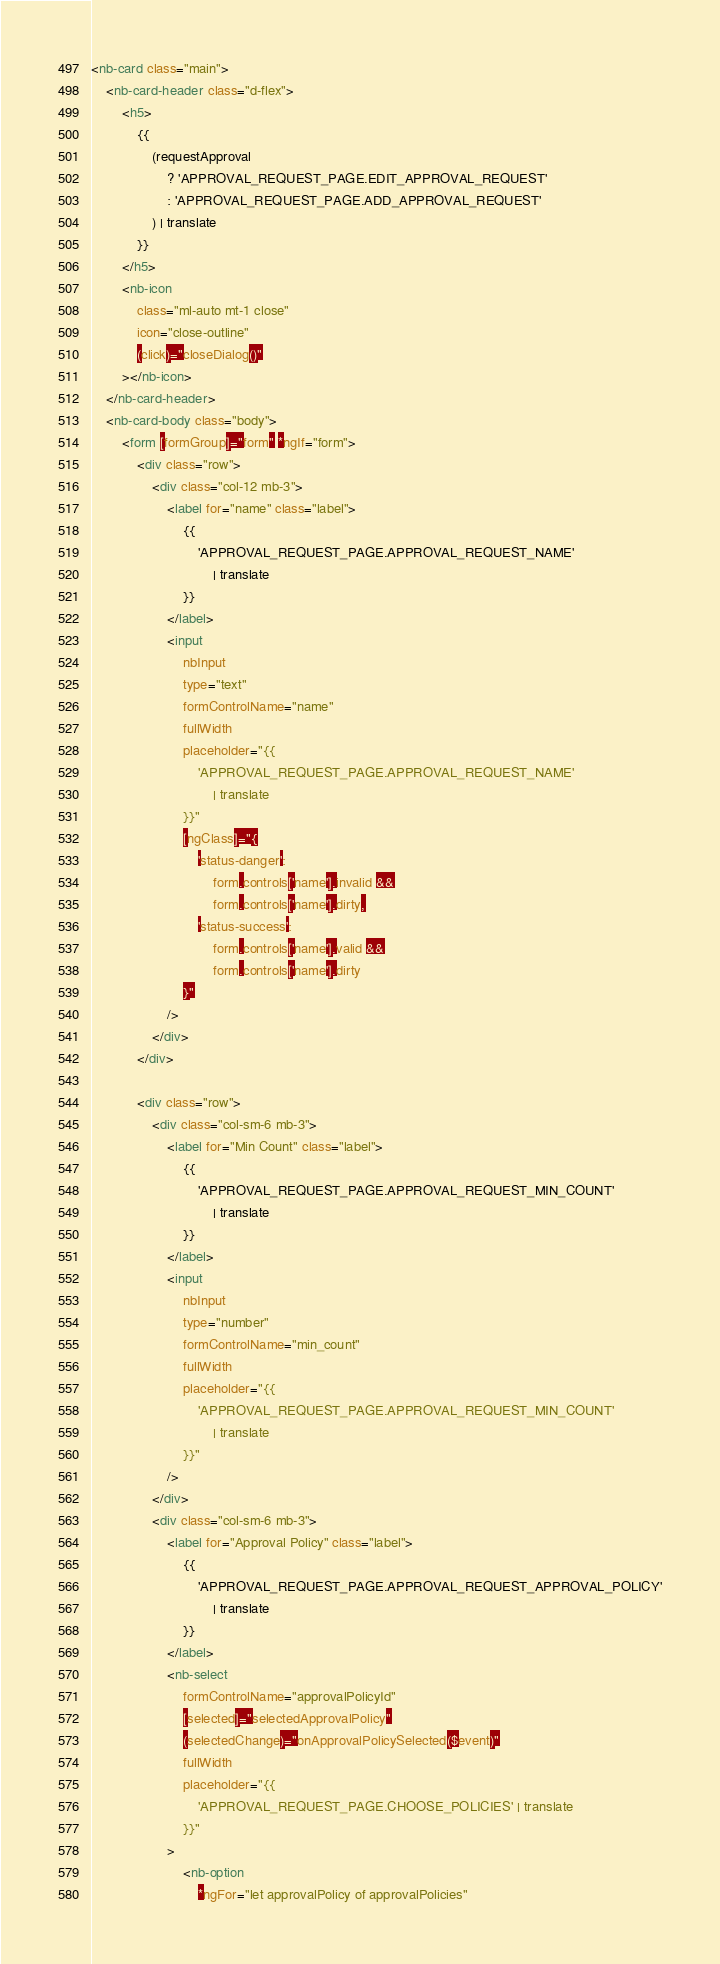Convert code to text. <code><loc_0><loc_0><loc_500><loc_500><_HTML_><nb-card class="main">
	<nb-card-header class="d-flex">
		<h5>
			{{
				(requestApproval
					? 'APPROVAL_REQUEST_PAGE.EDIT_APPROVAL_REQUEST'
					: 'APPROVAL_REQUEST_PAGE.ADD_APPROVAL_REQUEST'
				) | translate
			}}
		</h5>
		<nb-icon
			class="ml-auto mt-1 close"
			icon="close-outline"
			(click)="closeDialog()"
		></nb-icon>
	</nb-card-header>
	<nb-card-body class="body">
		<form [formGroup]="form" *ngIf="form">
			<div class="row">
				<div class="col-12 mb-3">
					<label for="name" class="label">
						{{
							'APPROVAL_REQUEST_PAGE.APPROVAL_REQUEST_NAME'
								| translate
						}}
					</label>
					<input
						nbInput
						type="text"
						formControlName="name"
						fullWidth
						placeholder="{{
							'APPROVAL_REQUEST_PAGE.APPROVAL_REQUEST_NAME'
								| translate
						}}"
						[ngClass]="{
							'status-danger':
								form.controls['name'].invalid &&
								form.controls['name'].dirty,
							'status-success':
								form.controls['name'].valid &&
								form.controls['name'].dirty
						}"
					/>
				</div>
			</div>

			<div class="row">
				<div class="col-sm-6 mb-3">
					<label for="Min Count" class="label">
						{{
							'APPROVAL_REQUEST_PAGE.APPROVAL_REQUEST_MIN_COUNT'
								| translate
						}}
					</label>
					<input
						nbInput
						type="number"
						formControlName="min_count"
						fullWidth
						placeholder="{{
							'APPROVAL_REQUEST_PAGE.APPROVAL_REQUEST_MIN_COUNT'
								| translate
						}}"
					/>
				</div>
				<div class="col-sm-6 mb-3">
					<label for="Approval Policy" class="label">
						{{
							'APPROVAL_REQUEST_PAGE.APPROVAL_REQUEST_APPROVAL_POLICY'
								| translate
						}}
					</label>
					<nb-select
						formControlName="approvalPolicyId"
						[selected]="selectedApprovalPolicy"
						(selectedChange)="onApprovalPolicySelected($event)"
						fullWidth
						placeholder="{{
							'APPROVAL_REQUEST_PAGE.CHOOSE_POLICIES' | translate
						}}"
					>
						<nb-option
							*ngFor="let approvalPolicy of approvalPolicies"</code> 